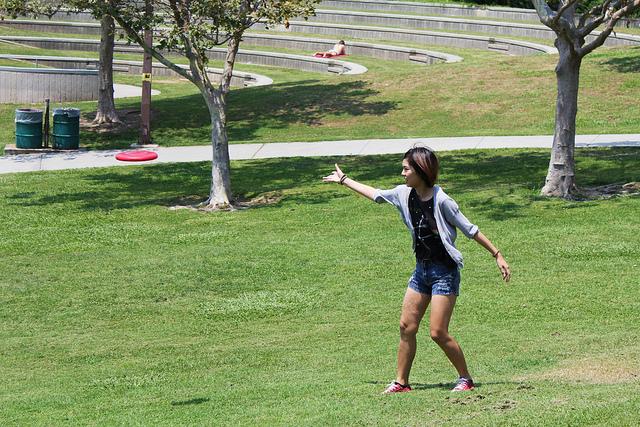What activity is the woman in this picture engaged in?
Write a very short answer. Frisbee. How many garbage cans can you see?
Be succinct. 2. Do the shoes have laces?
Short answer required. Yes. 